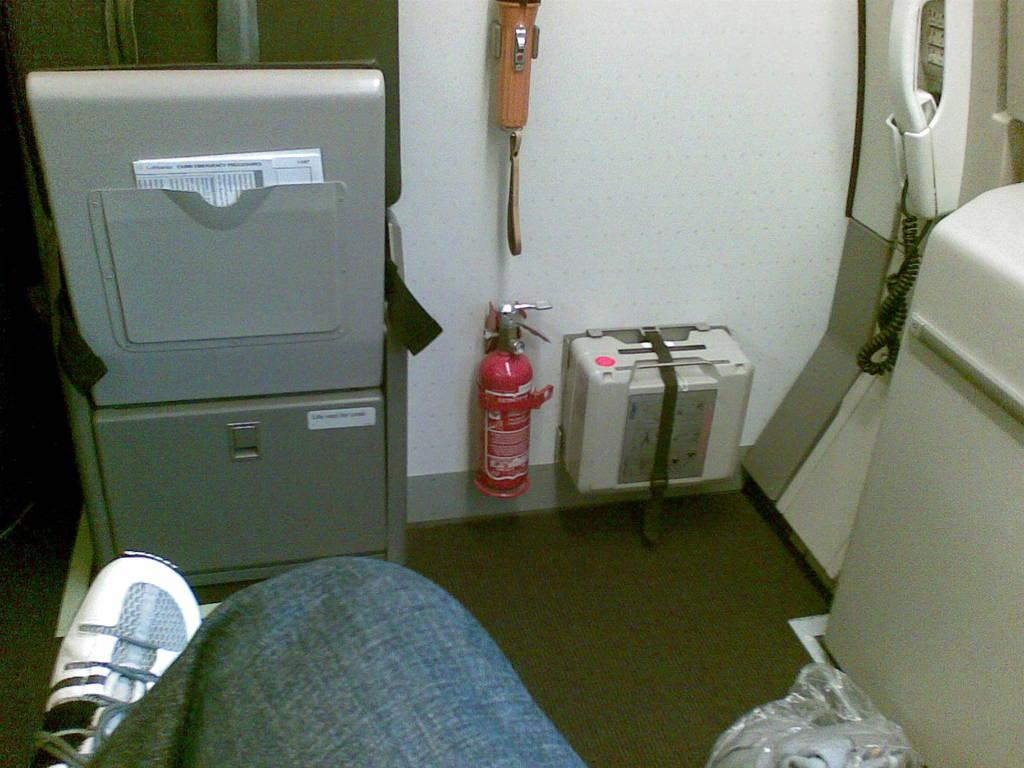What safety device is present in the image? There is a fire extinguisher in the image. What is another object that provides light in the image? There is a torch light in the image. What electronic device is visible in the image? There is a cell phone in the image. What type of cover is present in the image? There is a plastic cover in the image. What type of paper is present in the image? There is a paper in the image. What other unspecified objects can be seen in the image? There are some unspecified objects in the image. Can you describe any part of a person in the image? A person's leg is visible in the image. How many dogs are present in the image? There are no dogs present in the image. What type of milk is being consumed in the image? There is no milk present in the image. 